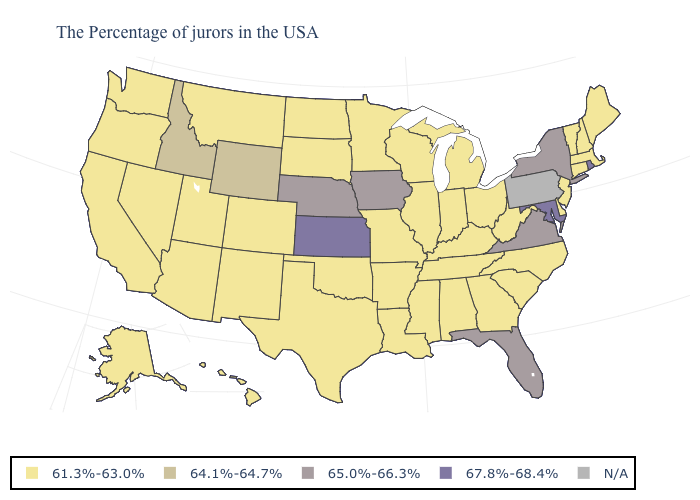What is the lowest value in the Northeast?
Write a very short answer. 61.3%-63.0%. What is the value of Idaho?
Be succinct. 64.1%-64.7%. Name the states that have a value in the range 61.3%-63.0%?
Give a very brief answer. Maine, Massachusetts, New Hampshire, Vermont, Connecticut, New Jersey, Delaware, North Carolina, South Carolina, West Virginia, Ohio, Georgia, Michigan, Kentucky, Indiana, Alabama, Tennessee, Wisconsin, Illinois, Mississippi, Louisiana, Missouri, Arkansas, Minnesota, Oklahoma, Texas, South Dakota, North Dakota, Colorado, New Mexico, Utah, Montana, Arizona, Nevada, California, Washington, Oregon, Alaska, Hawaii. Name the states that have a value in the range N/A?
Write a very short answer. Pennsylvania. What is the value of North Dakota?
Write a very short answer. 61.3%-63.0%. Among the states that border Illinois , does Missouri have the lowest value?
Answer briefly. Yes. Name the states that have a value in the range 61.3%-63.0%?
Give a very brief answer. Maine, Massachusetts, New Hampshire, Vermont, Connecticut, New Jersey, Delaware, North Carolina, South Carolina, West Virginia, Ohio, Georgia, Michigan, Kentucky, Indiana, Alabama, Tennessee, Wisconsin, Illinois, Mississippi, Louisiana, Missouri, Arkansas, Minnesota, Oklahoma, Texas, South Dakota, North Dakota, Colorado, New Mexico, Utah, Montana, Arizona, Nevada, California, Washington, Oregon, Alaska, Hawaii. Which states have the lowest value in the South?
Give a very brief answer. Delaware, North Carolina, South Carolina, West Virginia, Georgia, Kentucky, Alabama, Tennessee, Mississippi, Louisiana, Arkansas, Oklahoma, Texas. Does the map have missing data?
Short answer required. Yes. Among the states that border Massachusetts , does Connecticut have the highest value?
Concise answer only. No. Does Alaska have the lowest value in the West?
Quick response, please. Yes. What is the value of Arizona?
Short answer required. 61.3%-63.0%. Which states have the lowest value in the South?
Give a very brief answer. Delaware, North Carolina, South Carolina, West Virginia, Georgia, Kentucky, Alabama, Tennessee, Mississippi, Louisiana, Arkansas, Oklahoma, Texas. 